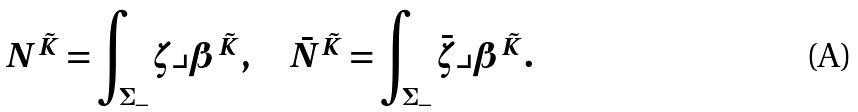Convert formula to latex. <formula><loc_0><loc_0><loc_500><loc_500>N ^ { \tilde { K } } = \int _ { \Sigma _ { - } } \zeta \lrcorner \beta ^ { \tilde { K } } , \quad \bar { N } ^ { \tilde { K } } = \int _ { \Sigma _ { - } } \bar { \zeta } \lrcorner \beta ^ { \tilde { K } } .</formula> 